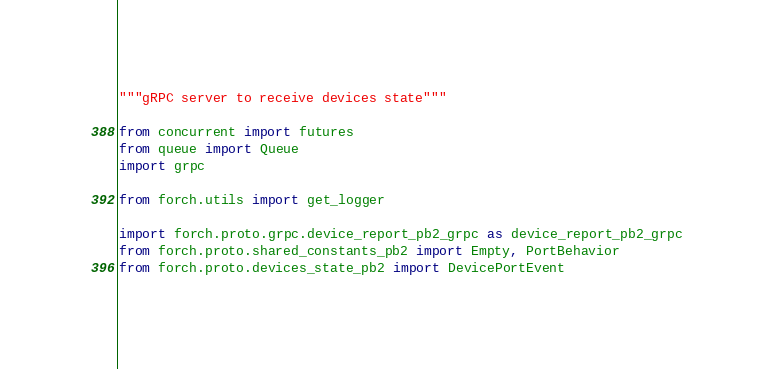<code> <loc_0><loc_0><loc_500><loc_500><_Python_>"""gRPC server to receive devices state"""

from concurrent import futures
from queue import Queue
import grpc

from forch.utils import get_logger

import forch.proto.grpc.device_report_pb2_grpc as device_report_pb2_grpc
from forch.proto.shared_constants_pb2 import Empty, PortBehavior
from forch.proto.devices_state_pb2 import DevicePortEvent
</code> 